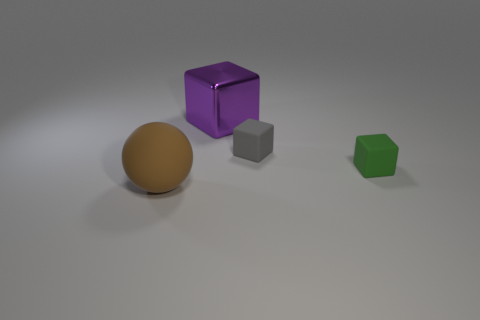Subtract all gray matte blocks. How many blocks are left? 2 Add 1 tiny rubber things. How many objects exist? 5 Subtract all gray cubes. How many cubes are left? 2 Subtract all cubes. How many objects are left? 1 Subtract 1 blocks. How many blocks are left? 2 Subtract all cyan cubes. Subtract all blue spheres. How many cubes are left? 3 Subtract all purple spheres. How many green cubes are left? 1 Subtract all big blue things. Subtract all small cubes. How many objects are left? 2 Add 1 tiny gray rubber objects. How many tiny gray rubber objects are left? 2 Add 2 small green matte cubes. How many small green matte cubes exist? 3 